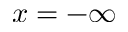Convert formula to latex. <formula><loc_0><loc_0><loc_500><loc_500>x = - \infty</formula> 